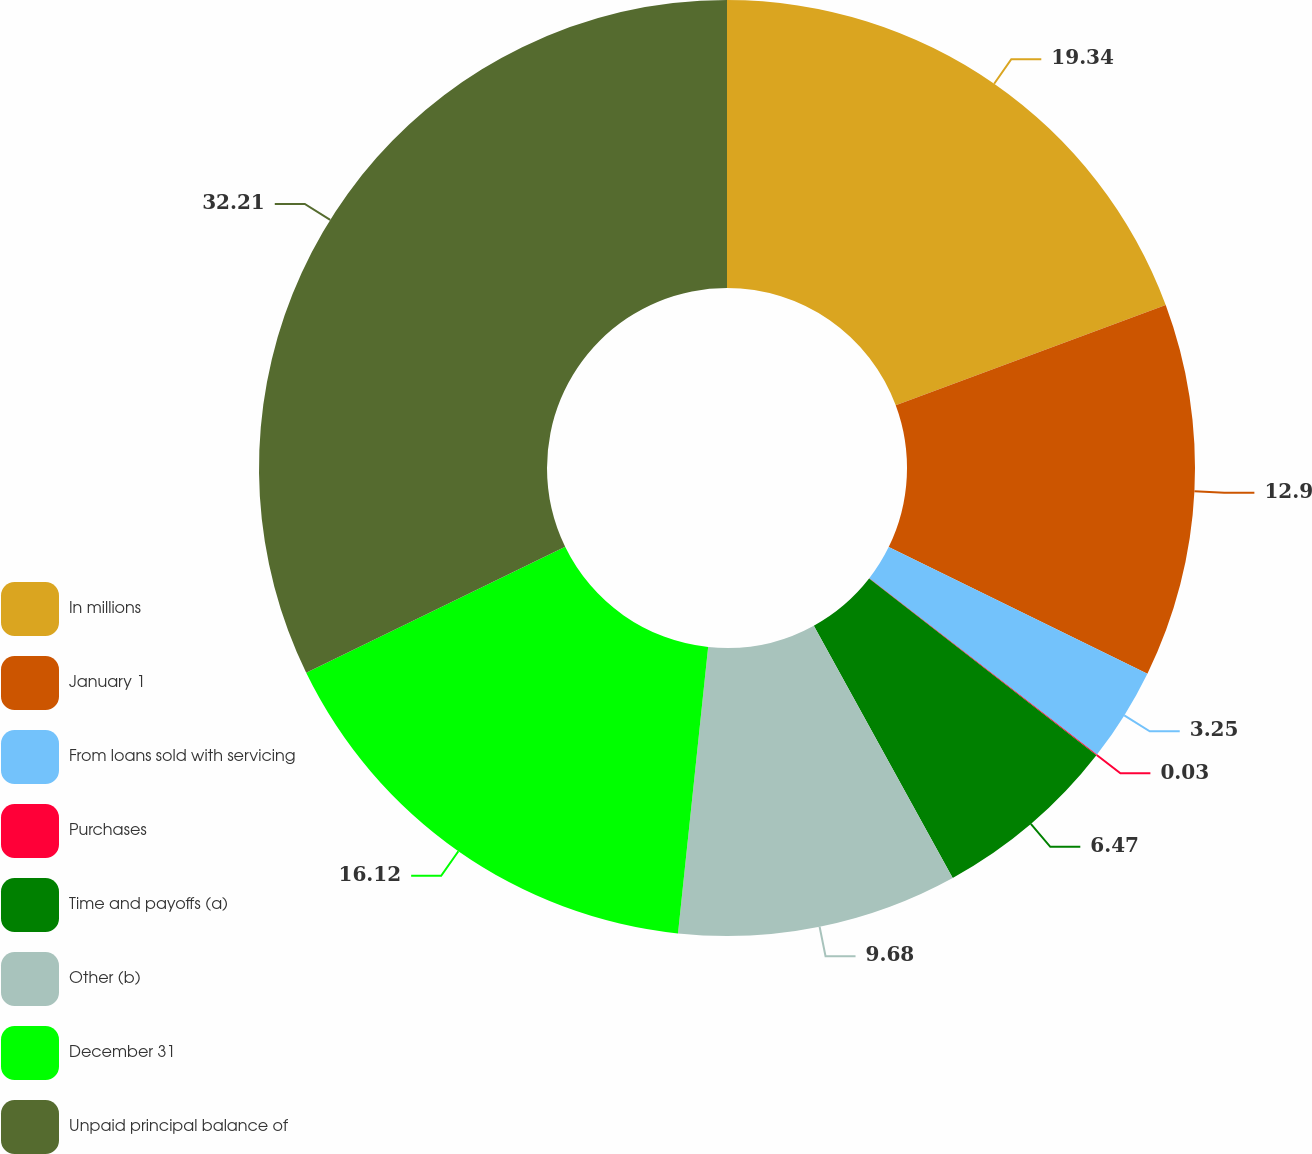Convert chart. <chart><loc_0><loc_0><loc_500><loc_500><pie_chart><fcel>In millions<fcel>January 1<fcel>From loans sold with servicing<fcel>Purchases<fcel>Time and payoffs (a)<fcel>Other (b)<fcel>December 31<fcel>Unpaid principal balance of<nl><fcel>19.34%<fcel>12.9%<fcel>3.25%<fcel>0.03%<fcel>6.47%<fcel>9.68%<fcel>16.12%<fcel>32.21%<nl></chart> 